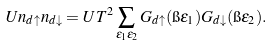<formula> <loc_0><loc_0><loc_500><loc_500>U n _ { d \uparrow } n _ { d \downarrow } = U T ^ { 2 } \sum _ { \epsilon _ { 1 } \epsilon _ { 2 } } G _ { d \uparrow } ( \i \epsilon _ { 1 } ) G _ { d \downarrow } ( \i \epsilon _ { 2 } ) .</formula> 